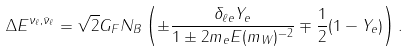Convert formula to latex. <formula><loc_0><loc_0><loc_500><loc_500>\Delta E ^ { \nu _ { \ell } , { \bar { \nu } } _ { \ell } } = \sqrt { 2 } G _ { F } N _ { B } \left ( \pm \frac { \delta _ { \ell e } Y _ { e } } { 1 \pm 2 m _ { e } E ( m _ { W } ) ^ { - 2 } } \mp \frac { 1 } { 2 } ( 1 - Y _ { e } ) \right ) { . }</formula> 